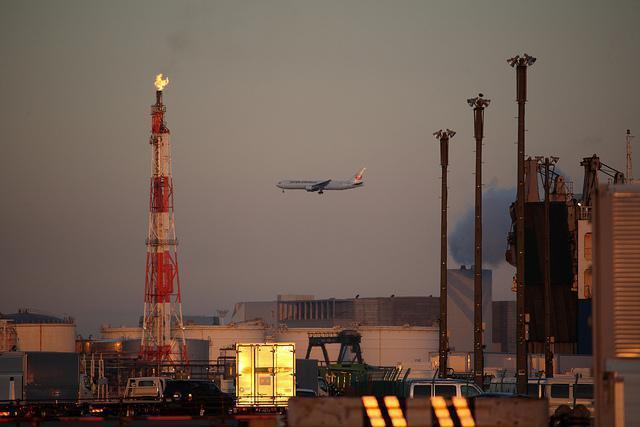How many cats are in the picture?
Give a very brief answer. 0. 